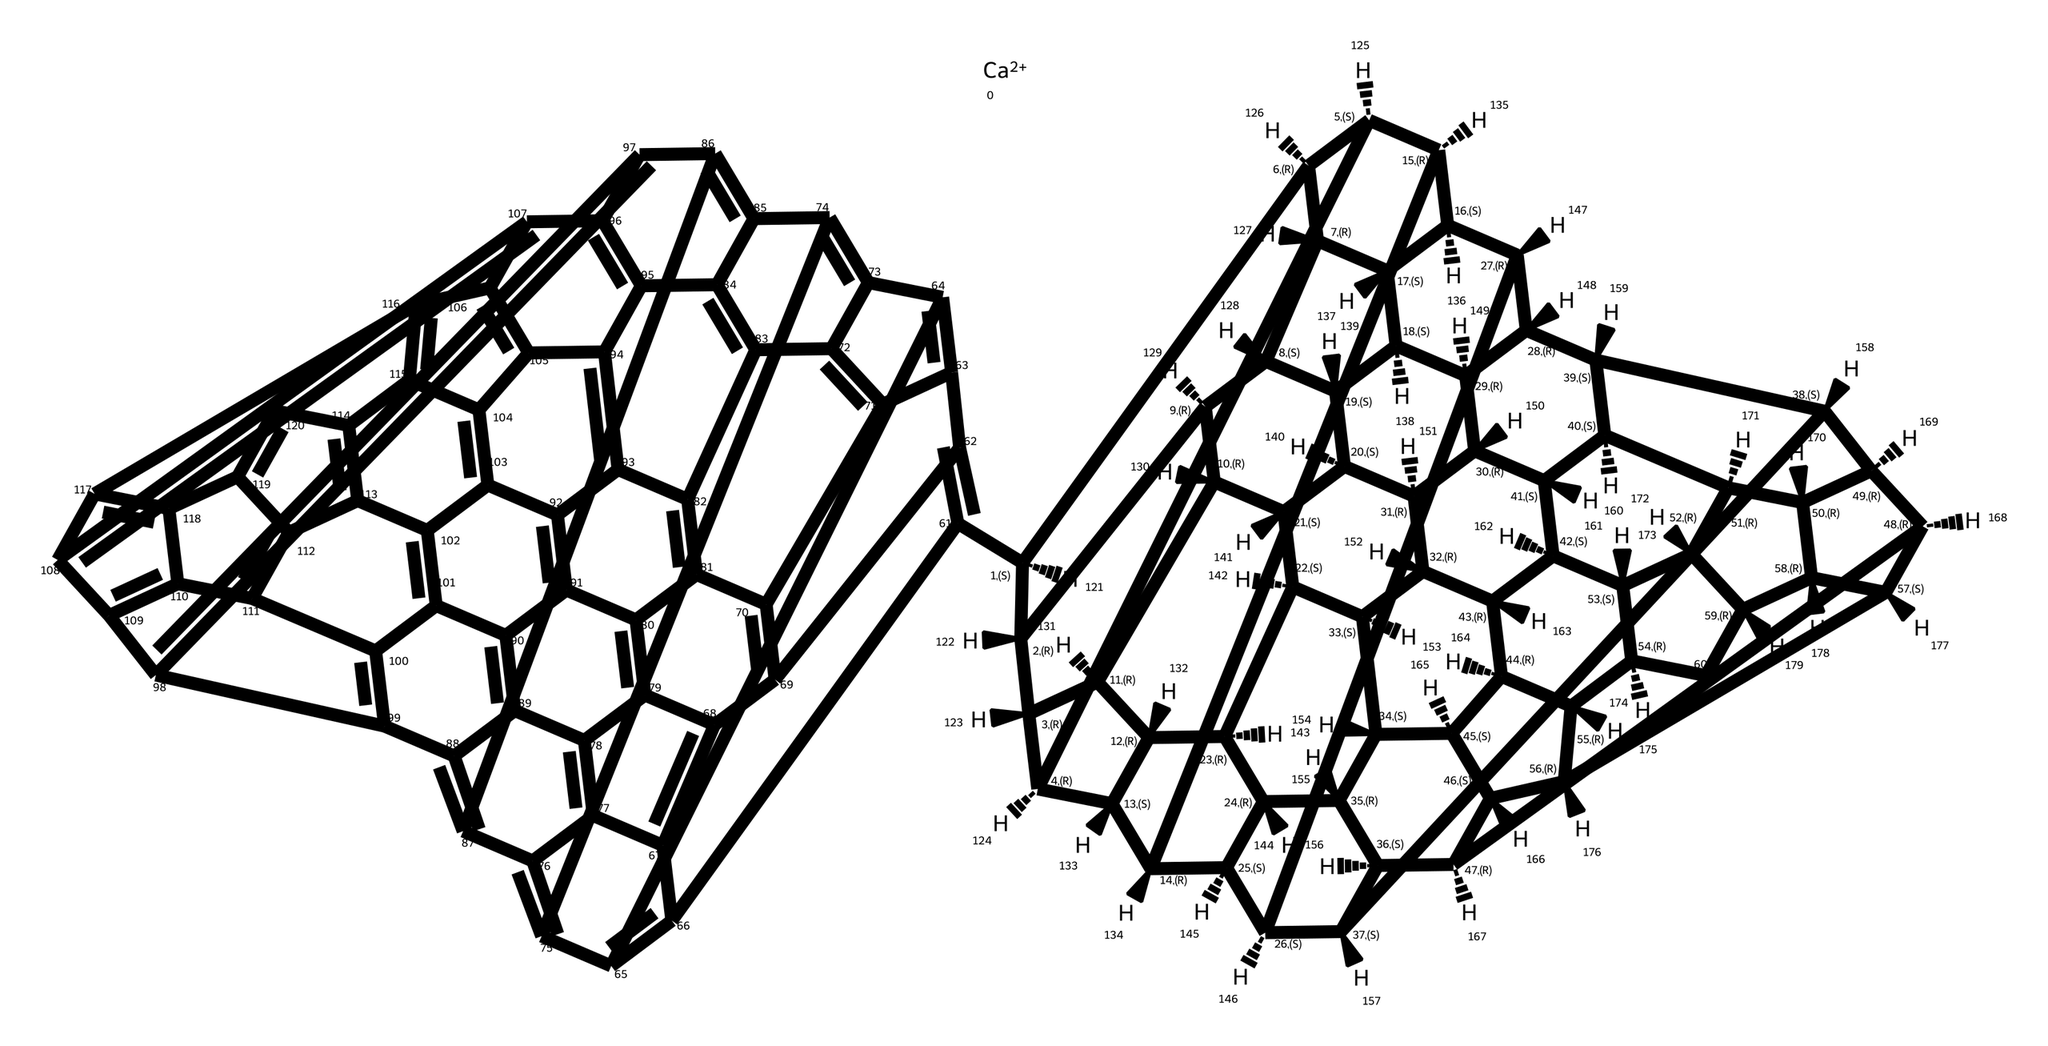What is the total number of carbon atoms in calcium fulleride? By analyzing the chemical structure, we see that the notation indicates a total of sixty carbon atoms represented in the fullerene cage structure.
Answer: sixty How many calcium atoms are present in this chemical? The chemical structure indicates the presence of one calcium atom, denoted by the [Ca+2] notation.
Answer: one What type of hybridization is observed in the carbon atoms of calcium fulleride? The carbon atoms in fullerides typically have sp2 hybridization, indicated by their bonding structure as part of the fullerene framework.
Answer: sp2 What is the role of calcium in calcium fulleride? Calcium acts as an electron donor, facilitating the stabilization of the fullerene structure through ionic bonding.
Answer: electron donor Describe the symmetry of the calcium fulleride molecular structure. The structure demonstrates high symmetry typical of fullerenes, with a regular arrangement across its vertices and edges, contributing to its overall stability.
Answer: high symmetry What is the coordination number of the calcium ion in this structure? The coordination number of the calcium ion can be determined by counting the number of carbon atoms it is directly bonded to, which is typically twelve in calcium fulleride.
Answer: twelve How does the structure of calcium fulleride contribute to its potential use in power systems? The unique structural and electronic properties of calcium fulleride, particularly its ability to store charge and high surface area, make it suitable for applications in power systems like batteries and supercapacitors.
Answer: suitable for power systems 